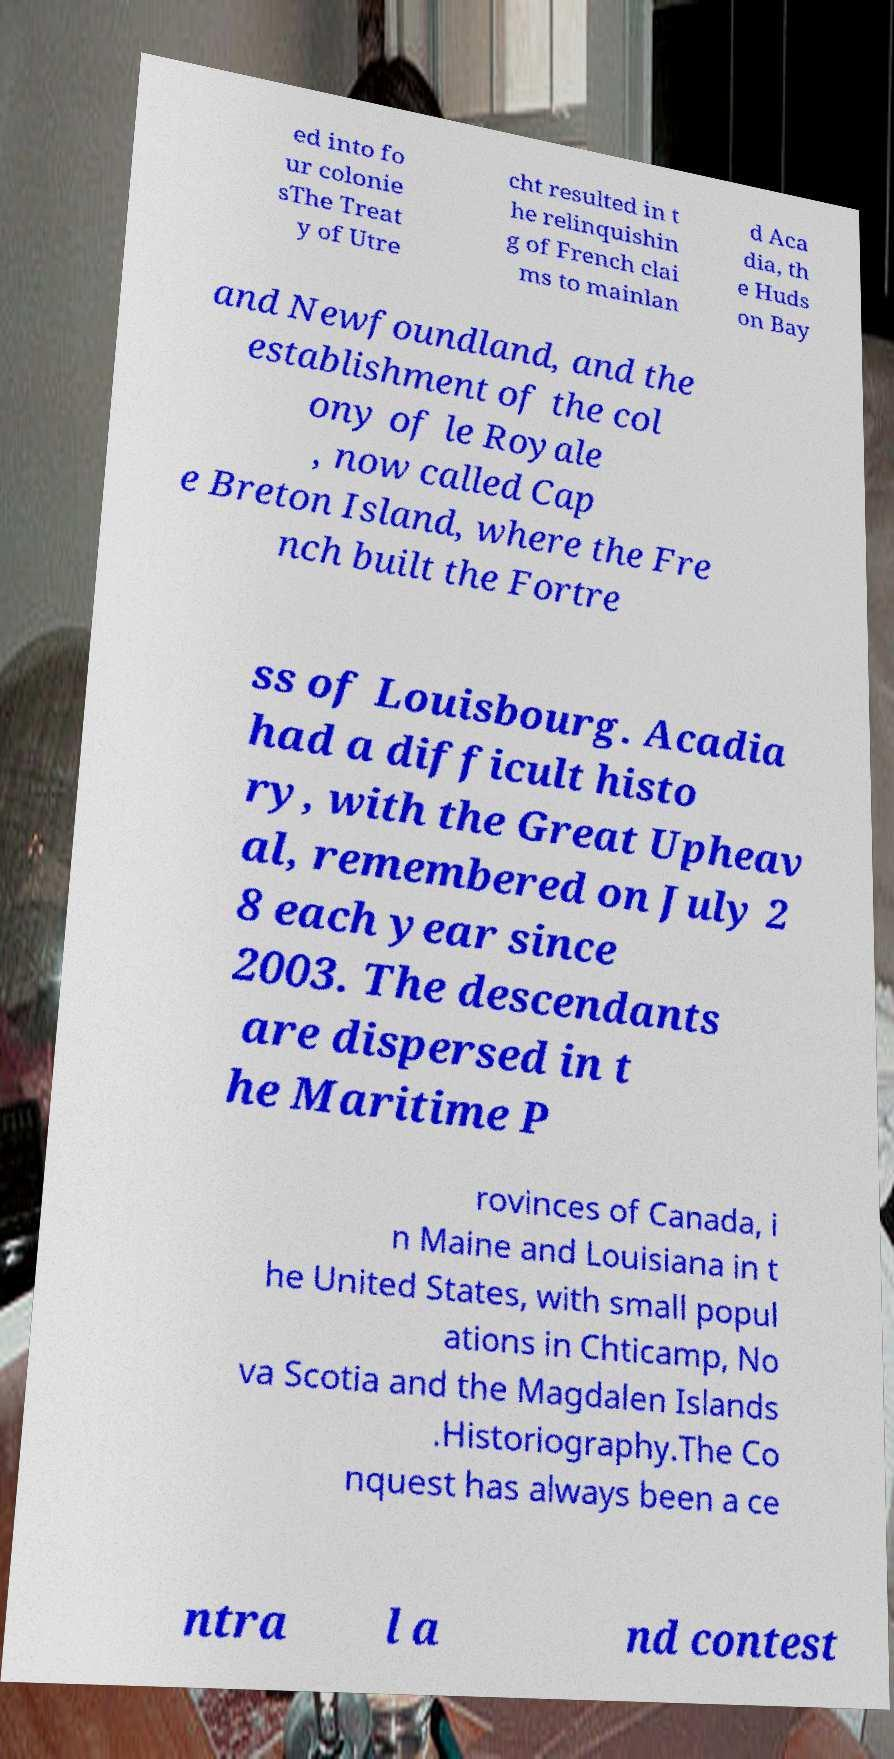Could you assist in decoding the text presented in this image and type it out clearly? ed into fo ur colonie sThe Treat y of Utre cht resulted in t he relinquishin g of French clai ms to mainlan d Aca dia, th e Huds on Bay and Newfoundland, and the establishment of the col ony of le Royale , now called Cap e Breton Island, where the Fre nch built the Fortre ss of Louisbourg. Acadia had a difficult histo ry, with the Great Upheav al, remembered on July 2 8 each year since 2003. The descendants are dispersed in t he Maritime P rovinces of Canada, i n Maine and Louisiana in t he United States, with small popul ations in Chticamp, No va Scotia and the Magdalen Islands .Historiography.The Co nquest has always been a ce ntra l a nd contest 